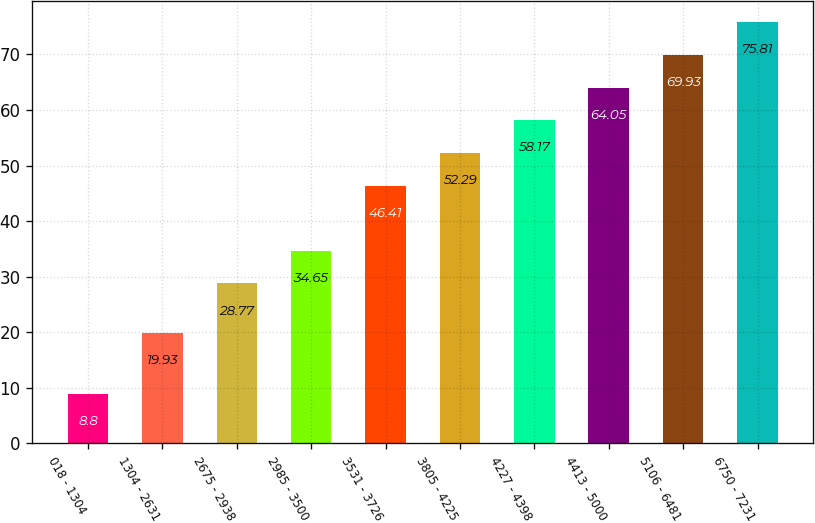<chart> <loc_0><loc_0><loc_500><loc_500><bar_chart><fcel>018 - 1304<fcel>1304 - 2631<fcel>2675 - 2938<fcel>2985 - 3500<fcel>3531 - 3726<fcel>3805 - 4225<fcel>4227 - 4398<fcel>4413 - 5000<fcel>5106 - 6481<fcel>6750 - 7231<nl><fcel>8.8<fcel>19.93<fcel>28.77<fcel>34.65<fcel>46.41<fcel>52.29<fcel>58.17<fcel>64.05<fcel>69.93<fcel>75.81<nl></chart> 